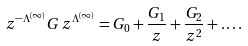<formula> <loc_0><loc_0><loc_500><loc_500>z ^ { - \Lambda ^ { ( \infty ) } } G \, z ^ { \Lambda ^ { ( \infty ) } } = G _ { 0 } + \frac { G _ { 1 } } { z } + \frac { G _ { 2 } } { z ^ { 2 } } + \dots .</formula> 